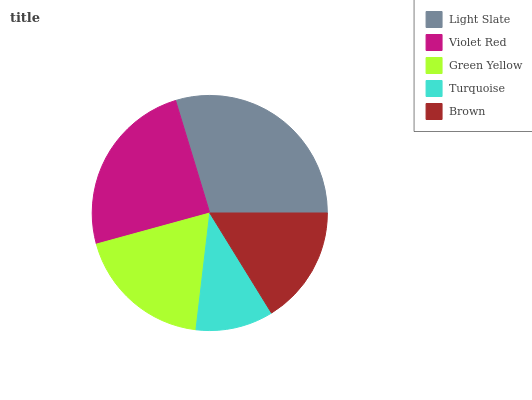Is Turquoise the minimum?
Answer yes or no. Yes. Is Light Slate the maximum?
Answer yes or no. Yes. Is Violet Red the minimum?
Answer yes or no. No. Is Violet Red the maximum?
Answer yes or no. No. Is Light Slate greater than Violet Red?
Answer yes or no. Yes. Is Violet Red less than Light Slate?
Answer yes or no. Yes. Is Violet Red greater than Light Slate?
Answer yes or no. No. Is Light Slate less than Violet Red?
Answer yes or no. No. Is Green Yellow the high median?
Answer yes or no. Yes. Is Green Yellow the low median?
Answer yes or no. Yes. Is Light Slate the high median?
Answer yes or no. No. Is Brown the low median?
Answer yes or no. No. 